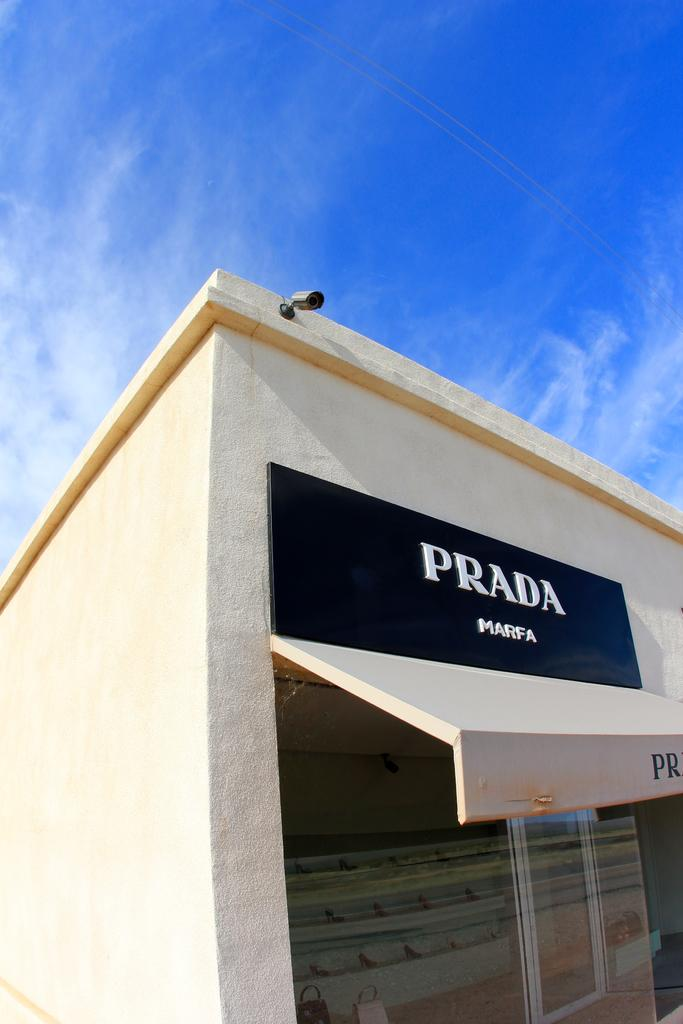What is on the wall of the building in the image? There is a name board on the wall of the building. Is there any other equipment near the name board? Yes, a CCTV camera is accompanied by the name board. What type of doors does the building have? The building has glass doors. What can be seen in the background of the image? There are clouds in the blue sky in the background of the image. How many plants are visible on the name board in the image? There are no plants visible on the name board in the image. Are there any brothers depicted on the name board in the image? There are no people, including brothers, depicted on the name board in the image. 